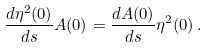<formula> <loc_0><loc_0><loc_500><loc_500>\frac { d \eta ^ { 2 } ( 0 ) } { d s } A ( 0 ) = \frac { d A ( 0 ) } { d s } \eta ^ { 2 } ( 0 ) \, .</formula> 